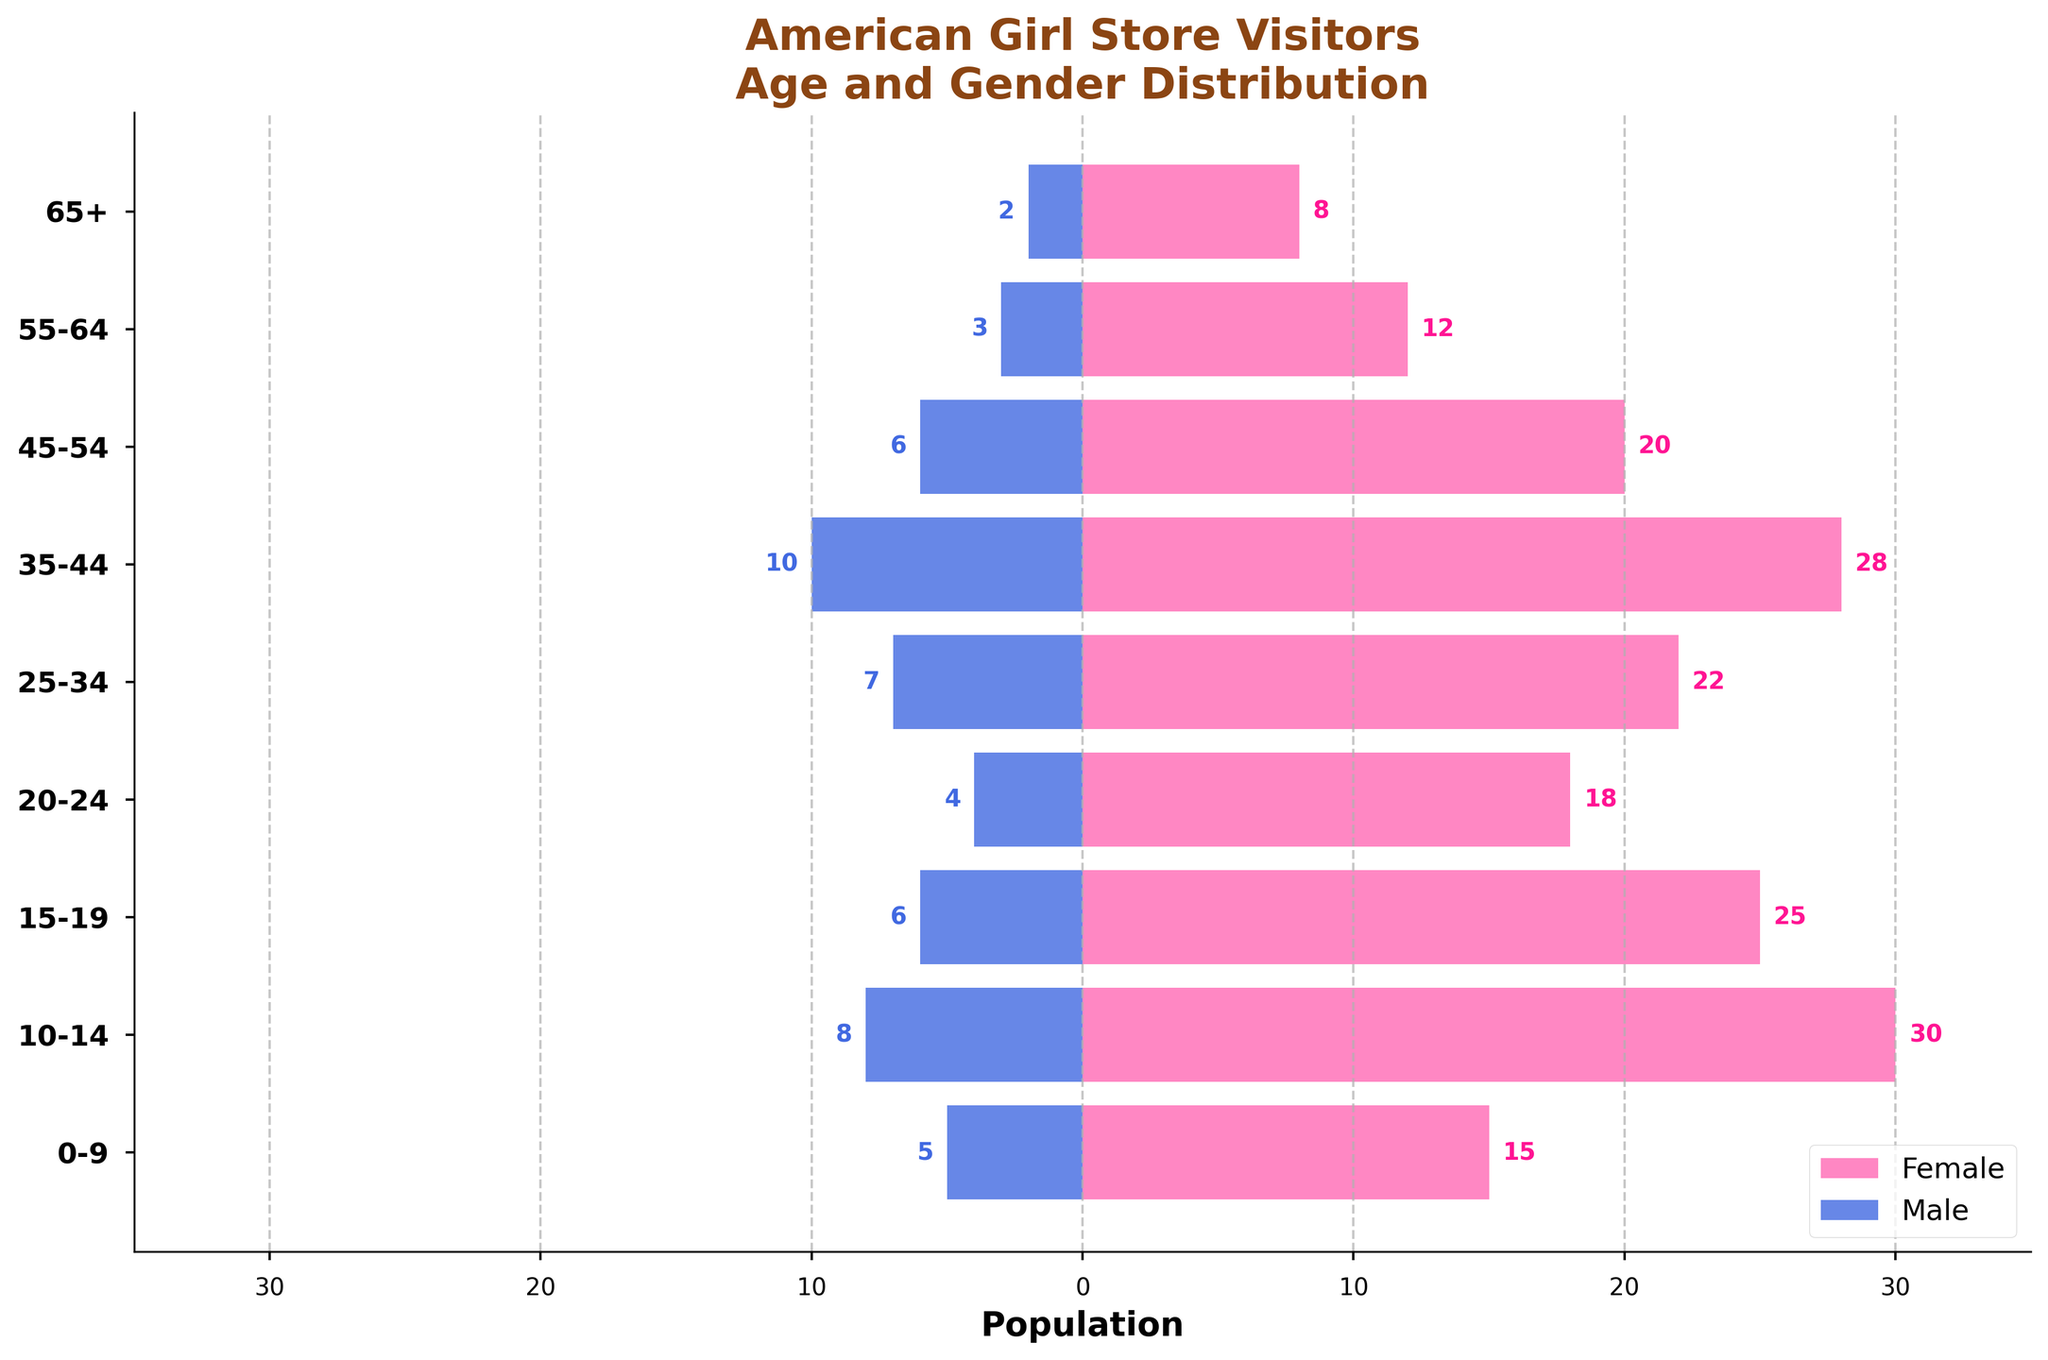How many age groups are depicted in the figure? Count the number of distinct age groups on the y-axis.
Answer: 9 Which age group has the most female visitors? Identify the age group corresponding to the highest bar on the female (left) side.
Answer: 10-14 How does the number of visitors aged 10-14 compare between males and females? Compare the length of the bars for males and females in the 10-14 age group.
Answer: More females Which age group has an equal number of male and female visitors? Identify age groups where the length of the bars for males and females are equal.
Answer: None What's the age group with the least gender difference in visitors? Calculate the absolute difference in the number of visitors between males and females for each age group and find the smallest difference.
Answer: 20-24 Which gender has higher representation in the older age groups (55+)? Analyze the bars for males and females in the 55-64 and 65+ age groups and compare them.
Answer: Female Are there more visitors aged 25-34 or 35-44? Compare the summed total of visitors in the 25-34 age group and the 35-44 age group.
Answer: 35-44 